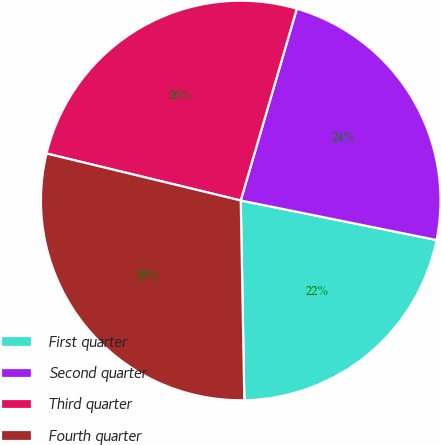Convert chart to OTSL. <chart><loc_0><loc_0><loc_500><loc_500><pie_chart><fcel>First quarter<fcel>Second quarter<fcel>Third quarter<fcel>Fourth quarter<nl><fcel>21.54%<fcel>23.64%<fcel>25.75%<fcel>29.06%<nl></chart> 